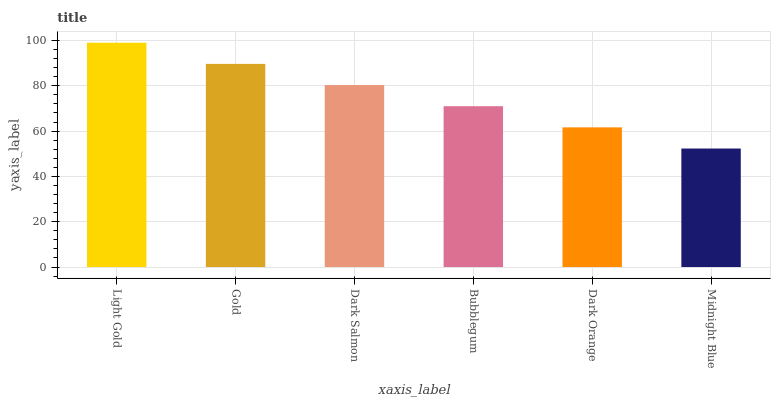Is Midnight Blue the minimum?
Answer yes or no. Yes. Is Light Gold the maximum?
Answer yes or no. Yes. Is Gold the minimum?
Answer yes or no. No. Is Gold the maximum?
Answer yes or no. No. Is Light Gold greater than Gold?
Answer yes or no. Yes. Is Gold less than Light Gold?
Answer yes or no. Yes. Is Gold greater than Light Gold?
Answer yes or no. No. Is Light Gold less than Gold?
Answer yes or no. No. Is Dark Salmon the high median?
Answer yes or no. Yes. Is Bubblegum the low median?
Answer yes or no. Yes. Is Midnight Blue the high median?
Answer yes or no. No. Is Midnight Blue the low median?
Answer yes or no. No. 